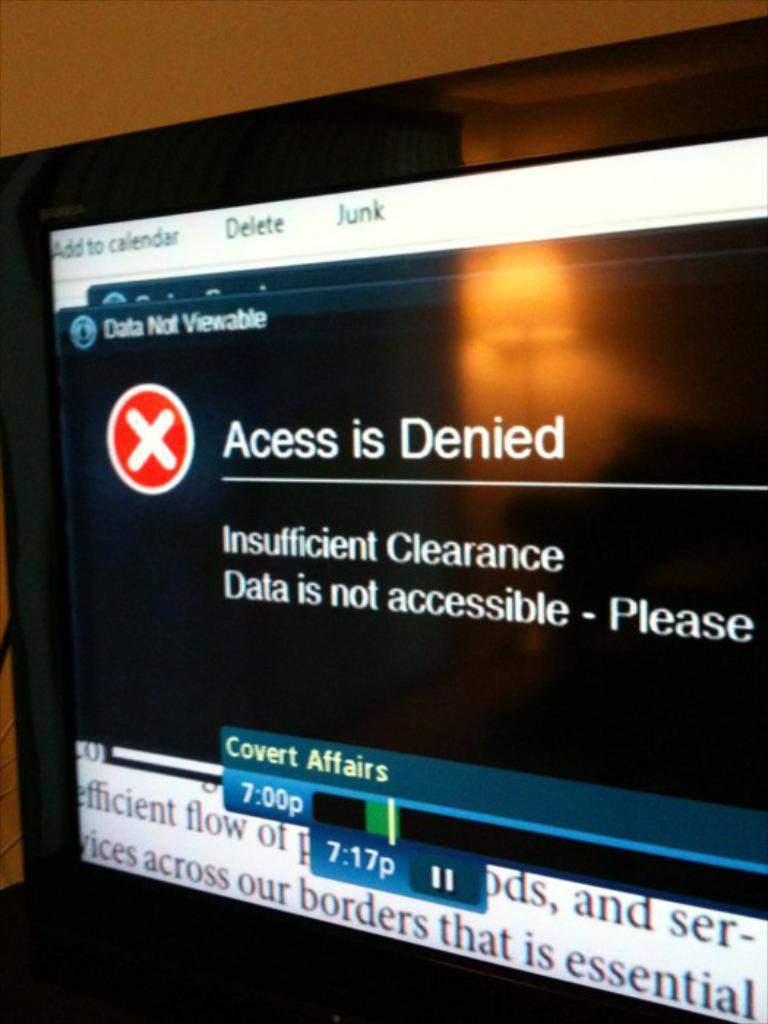What is the main object in the image? There is a screen in the image. What can be seen on the screen? There is text and numbers on the screen. What type of quince is being used to create a rhythm in the image? There is no quince or rhythm present in the image; it only features a screen with text and numbers. 